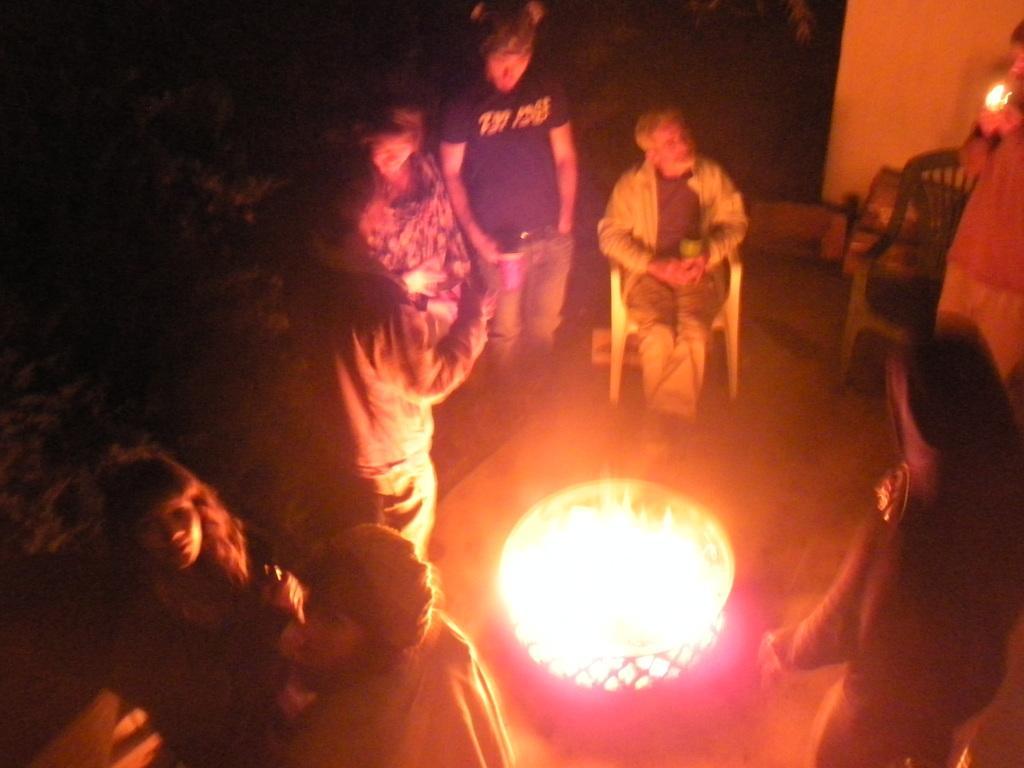In one or two sentences, can you explain what this image depicts? The old man in black T-shirt is sitting on the chair. Beside him, we see people standing around the fire. Behind them, we see a white wall and on the left corner of the picture, it is black in color. This picture might be clicked in the dark. 